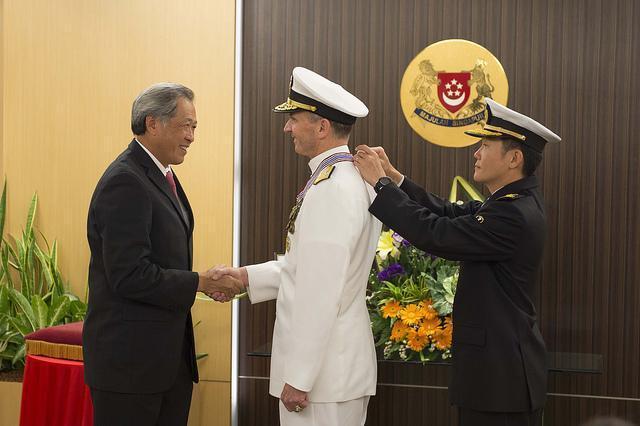How many men are not wearing hats?
Give a very brief answer. 1. How many people are in the photo?
Give a very brief answer. 3. How many potted plants are there?
Give a very brief answer. 2. 